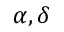<formula> <loc_0><loc_0><loc_500><loc_500>\alpha , \delta</formula> 